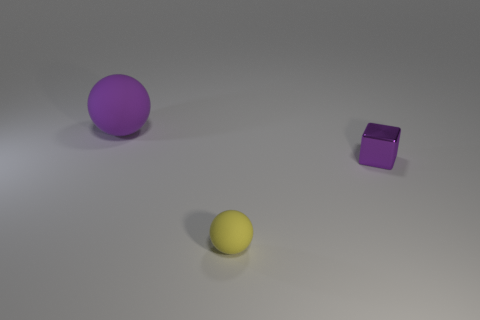There is a rubber ball that is on the right side of the matte sphere left of the matte ball in front of the big purple thing; what is its size? The rubber ball in question appears small relative to the surrounding objects, particularly if compared to the large purple sphere. Its size is more directly comparable to that of the nearby purple cube, suggesting that 'small' is a suitable description for its size within the context of this scene. 